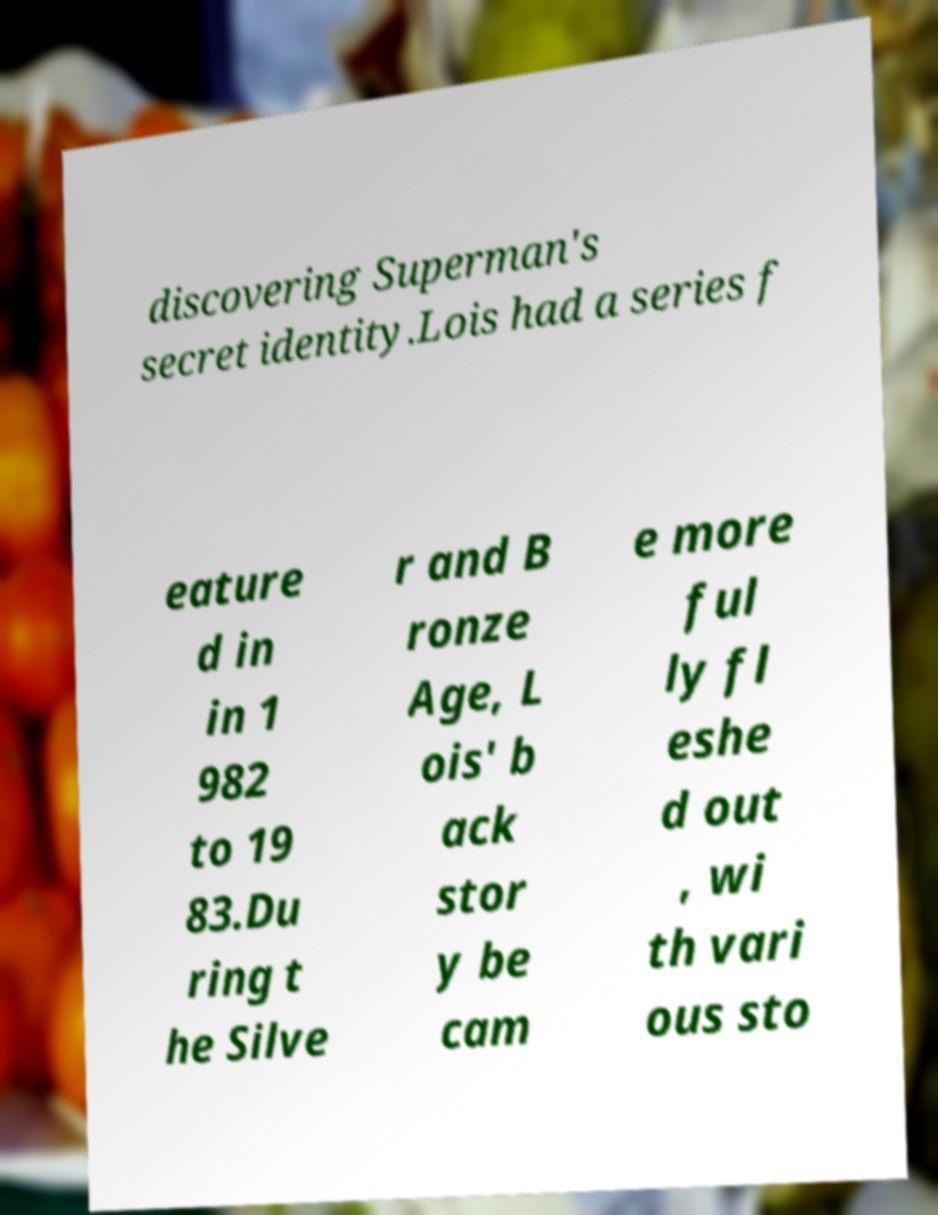There's text embedded in this image that I need extracted. Can you transcribe it verbatim? discovering Superman's secret identity.Lois had a series f eature d in in 1 982 to 19 83.Du ring t he Silve r and B ronze Age, L ois' b ack stor y be cam e more ful ly fl eshe d out , wi th vari ous sto 